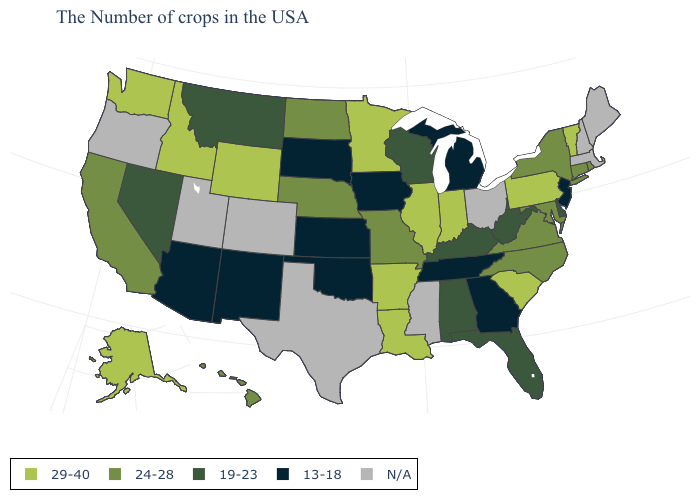What is the value of Hawaii?
Short answer required. 24-28. What is the highest value in the MidWest ?
Quick response, please. 29-40. Is the legend a continuous bar?
Write a very short answer. No. Does Nevada have the highest value in the West?
Short answer required. No. What is the value of West Virginia?
Concise answer only. 19-23. Among the states that border Texas , does Oklahoma have the highest value?
Be succinct. No. Among the states that border New York , does New Jersey have the highest value?
Give a very brief answer. No. Name the states that have a value in the range 19-23?
Give a very brief answer. Delaware, West Virginia, Florida, Kentucky, Alabama, Wisconsin, Montana, Nevada. Does the first symbol in the legend represent the smallest category?
Be succinct. No. Name the states that have a value in the range 24-28?
Keep it brief. Rhode Island, Connecticut, New York, Maryland, Virginia, North Carolina, Missouri, Nebraska, North Dakota, California, Hawaii. Name the states that have a value in the range 29-40?
Concise answer only. Vermont, Pennsylvania, South Carolina, Indiana, Illinois, Louisiana, Arkansas, Minnesota, Wyoming, Idaho, Washington, Alaska. Among the states that border Florida , does Georgia have the highest value?
Be succinct. No. What is the value of Colorado?
Answer briefly. N/A. 